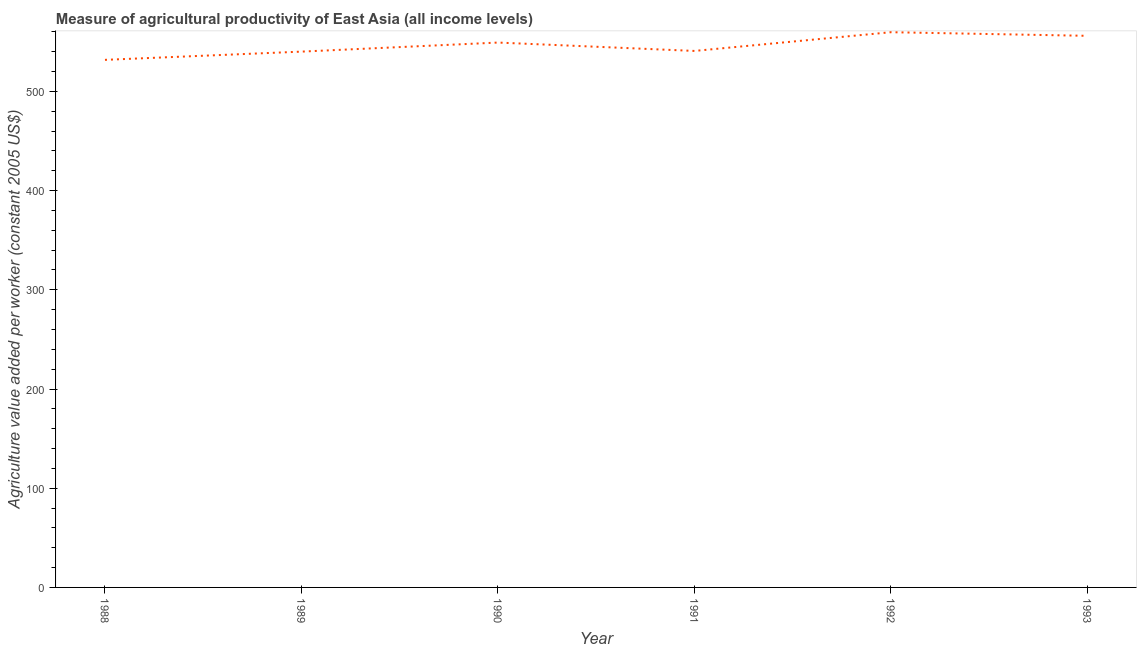What is the agriculture value added per worker in 1992?
Ensure brevity in your answer.  559.63. Across all years, what is the maximum agriculture value added per worker?
Ensure brevity in your answer.  559.63. Across all years, what is the minimum agriculture value added per worker?
Your answer should be very brief. 531.76. In which year was the agriculture value added per worker maximum?
Your answer should be compact. 1992. In which year was the agriculture value added per worker minimum?
Your response must be concise. 1988. What is the sum of the agriculture value added per worker?
Offer a very short reply. 3277.37. What is the difference between the agriculture value added per worker in 1992 and 1993?
Provide a short and direct response. 3.65. What is the average agriculture value added per worker per year?
Provide a short and direct response. 546.23. What is the median agriculture value added per worker?
Offer a terse response. 544.97. What is the ratio of the agriculture value added per worker in 1990 to that in 1991?
Ensure brevity in your answer.  1.02. Is the difference between the agriculture value added per worker in 1988 and 1993 greater than the difference between any two years?
Offer a very short reply. No. What is the difference between the highest and the second highest agriculture value added per worker?
Give a very brief answer. 3.65. What is the difference between the highest and the lowest agriculture value added per worker?
Offer a very short reply. 27.86. In how many years, is the agriculture value added per worker greater than the average agriculture value added per worker taken over all years?
Your answer should be compact. 3. How many lines are there?
Offer a very short reply. 1. How many years are there in the graph?
Provide a short and direct response. 6. What is the difference between two consecutive major ticks on the Y-axis?
Provide a short and direct response. 100. Are the values on the major ticks of Y-axis written in scientific E-notation?
Offer a very short reply. No. Does the graph contain any zero values?
Offer a terse response. No. What is the title of the graph?
Provide a short and direct response. Measure of agricultural productivity of East Asia (all income levels). What is the label or title of the Y-axis?
Offer a very short reply. Agriculture value added per worker (constant 2005 US$). What is the Agriculture value added per worker (constant 2005 US$) in 1988?
Give a very brief answer. 531.76. What is the Agriculture value added per worker (constant 2005 US$) of 1989?
Your answer should be very brief. 540.06. What is the Agriculture value added per worker (constant 2005 US$) in 1990?
Make the answer very short. 549.2. What is the Agriculture value added per worker (constant 2005 US$) of 1991?
Make the answer very short. 540.74. What is the Agriculture value added per worker (constant 2005 US$) in 1992?
Provide a short and direct response. 559.63. What is the Agriculture value added per worker (constant 2005 US$) in 1993?
Your response must be concise. 555.98. What is the difference between the Agriculture value added per worker (constant 2005 US$) in 1988 and 1989?
Give a very brief answer. -8.3. What is the difference between the Agriculture value added per worker (constant 2005 US$) in 1988 and 1990?
Keep it short and to the point. -17.43. What is the difference between the Agriculture value added per worker (constant 2005 US$) in 1988 and 1991?
Provide a succinct answer. -8.98. What is the difference between the Agriculture value added per worker (constant 2005 US$) in 1988 and 1992?
Make the answer very short. -27.86. What is the difference between the Agriculture value added per worker (constant 2005 US$) in 1988 and 1993?
Give a very brief answer. -24.22. What is the difference between the Agriculture value added per worker (constant 2005 US$) in 1989 and 1990?
Offer a terse response. -9.13. What is the difference between the Agriculture value added per worker (constant 2005 US$) in 1989 and 1991?
Offer a very short reply. -0.68. What is the difference between the Agriculture value added per worker (constant 2005 US$) in 1989 and 1992?
Keep it short and to the point. -19.56. What is the difference between the Agriculture value added per worker (constant 2005 US$) in 1989 and 1993?
Your answer should be compact. -15.92. What is the difference between the Agriculture value added per worker (constant 2005 US$) in 1990 and 1991?
Keep it short and to the point. 8.45. What is the difference between the Agriculture value added per worker (constant 2005 US$) in 1990 and 1992?
Ensure brevity in your answer.  -10.43. What is the difference between the Agriculture value added per worker (constant 2005 US$) in 1990 and 1993?
Give a very brief answer. -6.78. What is the difference between the Agriculture value added per worker (constant 2005 US$) in 1991 and 1992?
Offer a very short reply. -18.88. What is the difference between the Agriculture value added per worker (constant 2005 US$) in 1991 and 1993?
Give a very brief answer. -15.24. What is the difference between the Agriculture value added per worker (constant 2005 US$) in 1992 and 1993?
Provide a succinct answer. 3.65. What is the ratio of the Agriculture value added per worker (constant 2005 US$) in 1988 to that in 1989?
Provide a succinct answer. 0.98. What is the ratio of the Agriculture value added per worker (constant 2005 US$) in 1988 to that in 1991?
Provide a short and direct response. 0.98. What is the ratio of the Agriculture value added per worker (constant 2005 US$) in 1988 to that in 1992?
Your response must be concise. 0.95. What is the ratio of the Agriculture value added per worker (constant 2005 US$) in 1988 to that in 1993?
Your answer should be very brief. 0.96. What is the ratio of the Agriculture value added per worker (constant 2005 US$) in 1989 to that in 1990?
Make the answer very short. 0.98. What is the ratio of the Agriculture value added per worker (constant 2005 US$) in 1989 to that in 1992?
Provide a succinct answer. 0.96. What is the ratio of the Agriculture value added per worker (constant 2005 US$) in 1990 to that in 1991?
Provide a short and direct response. 1.02. What is the ratio of the Agriculture value added per worker (constant 2005 US$) in 1990 to that in 1992?
Provide a short and direct response. 0.98. What is the ratio of the Agriculture value added per worker (constant 2005 US$) in 1990 to that in 1993?
Offer a very short reply. 0.99. What is the ratio of the Agriculture value added per worker (constant 2005 US$) in 1991 to that in 1992?
Your answer should be compact. 0.97. 